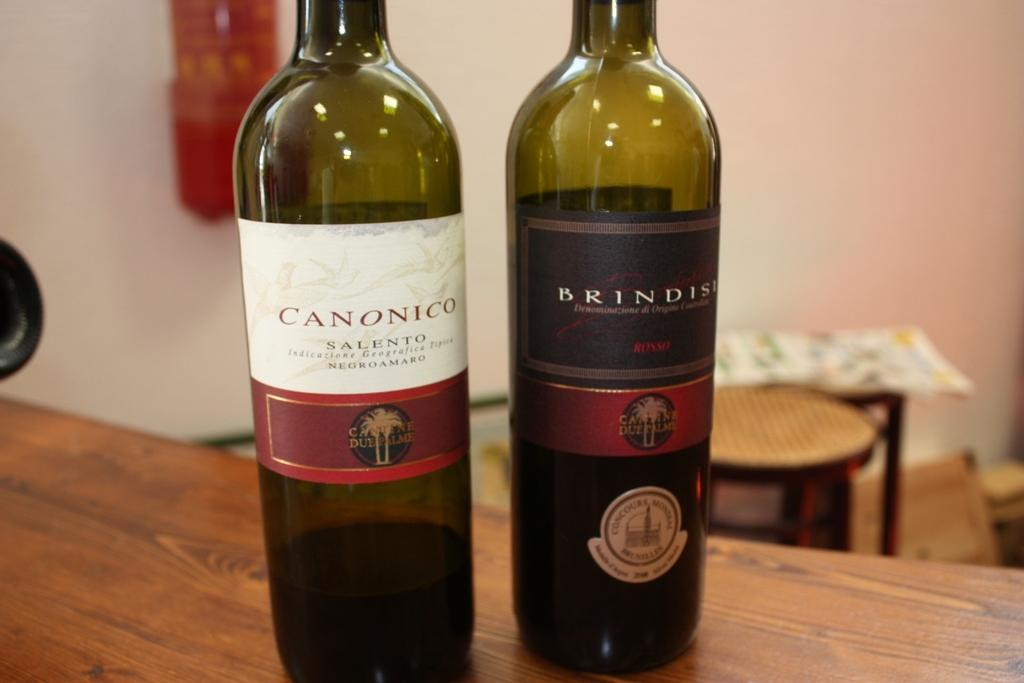<image>
Summarize the visual content of the image. A green Canonico wine bottle sits next to another bottle. 